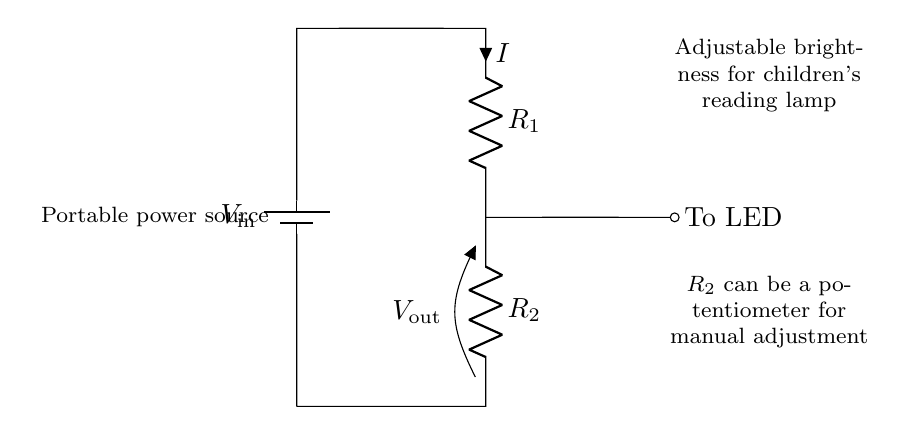What is the input voltage for this circuit? The input voltage is indicated as \(V_\text{in}\), which is connected directly to the battery at the top of the circuit diagram. Since no actual value is specified, we refer to it as \(V_\text{in}\).
Answer: \(V_\text{in}\) What type of resistors are used in the circuit? The circuit features two resistors labeled as \(R_1\) and \(R_2\). Resistor \(R_2\) is noted as a potentiometer, which allows for its value to be adjusted.
Answer: \(R_1\) and \(R_2\) (potentiometer) What is the purpose of the potentiometer in this circuit? The potentiometer \(R_2\) can be adjusted manually, which allows for changing the resistance, thereby controlling the output voltage \(V_\text{out}\) and the brightness of the LED connected to it.
Answer: Brightness control What does the output voltage represent in this circuit? The output voltage \(V_\text{out}\) is the voltage drop across the resistor \(R_2\). This voltage is what powers the LED and is adjusted by changing the resistance of \(R_2\).
Answer: Voltage drop across \(R_2\) How does current flow through this circuit? Current \(I\) flows from the battery, through \(R_1\), into \(R_2\), and then to the LED. The direction is shown as going from higher potential at the battery to lower potential at the output.
Answer: From battery to LED through \(R_1\) and \(R_2\) What is the relationship between the resistors and the output voltage? The output voltage \(V_\text{out}\) is determined by the ratio of the resistor values \(R_1\) and \(R_2\), according to the voltage divider rule, which states \(V_\text{out} = \frac{R_2}{R_1 + R_2} \times V_\text{in}\). This means as \(R_2\) increases, \(V_\text{out}\) also increases, allowing for more brightness.
Answer: Voltage divider rule 